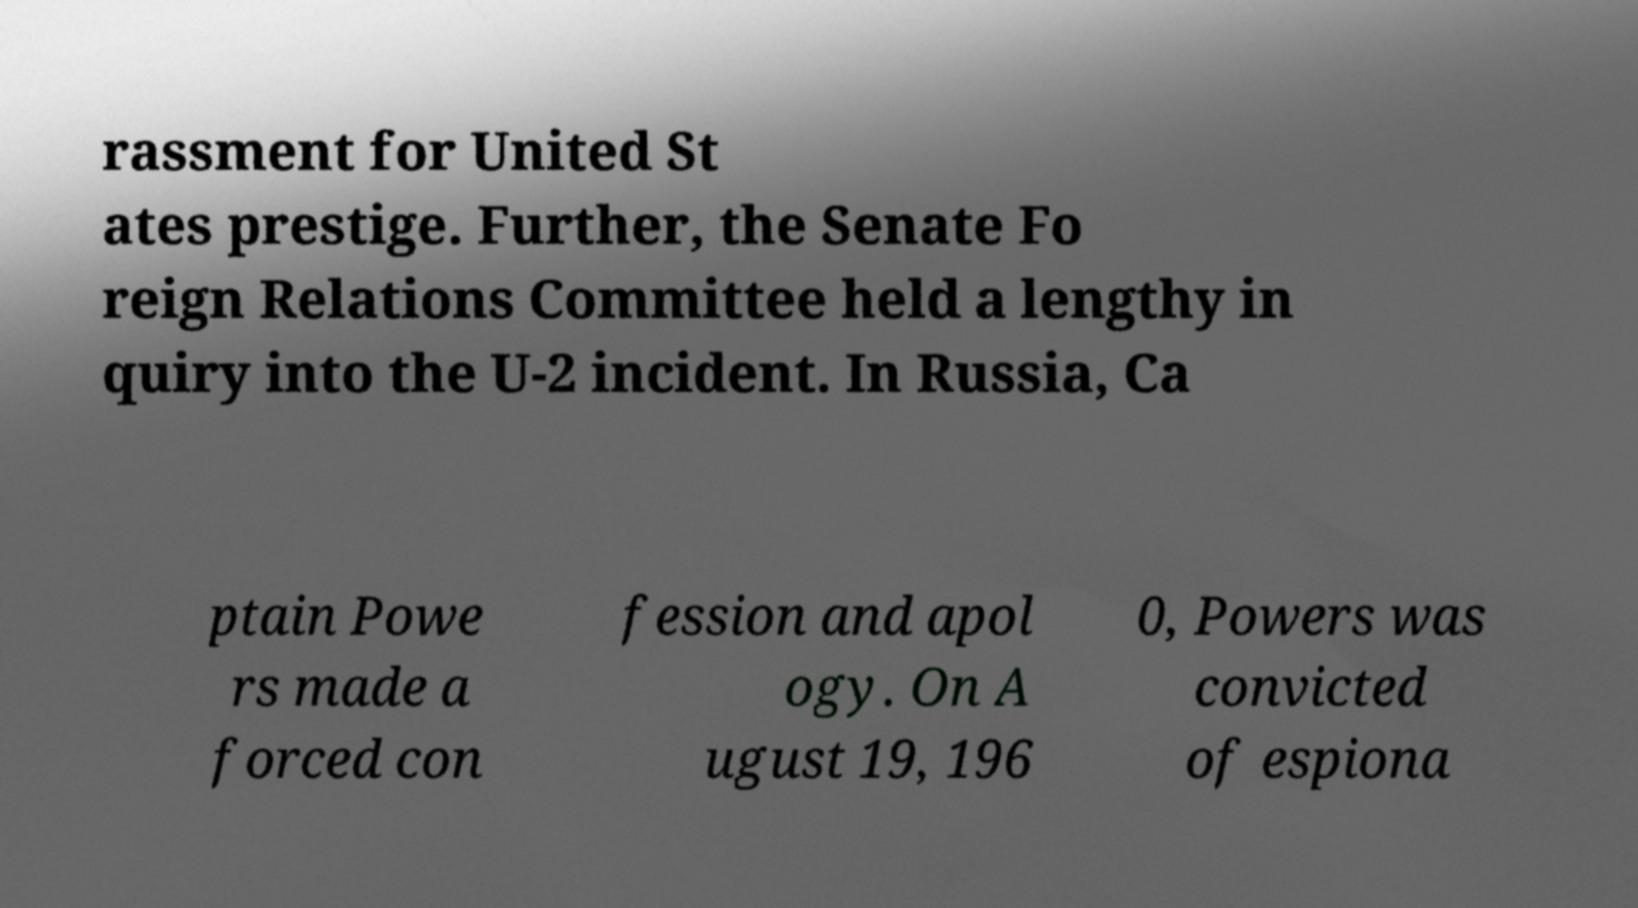I need the written content from this picture converted into text. Can you do that? rassment for United St ates prestige. Further, the Senate Fo reign Relations Committee held a lengthy in quiry into the U-2 incident. In Russia, Ca ptain Powe rs made a forced con fession and apol ogy. On A ugust 19, 196 0, Powers was convicted of espiona 